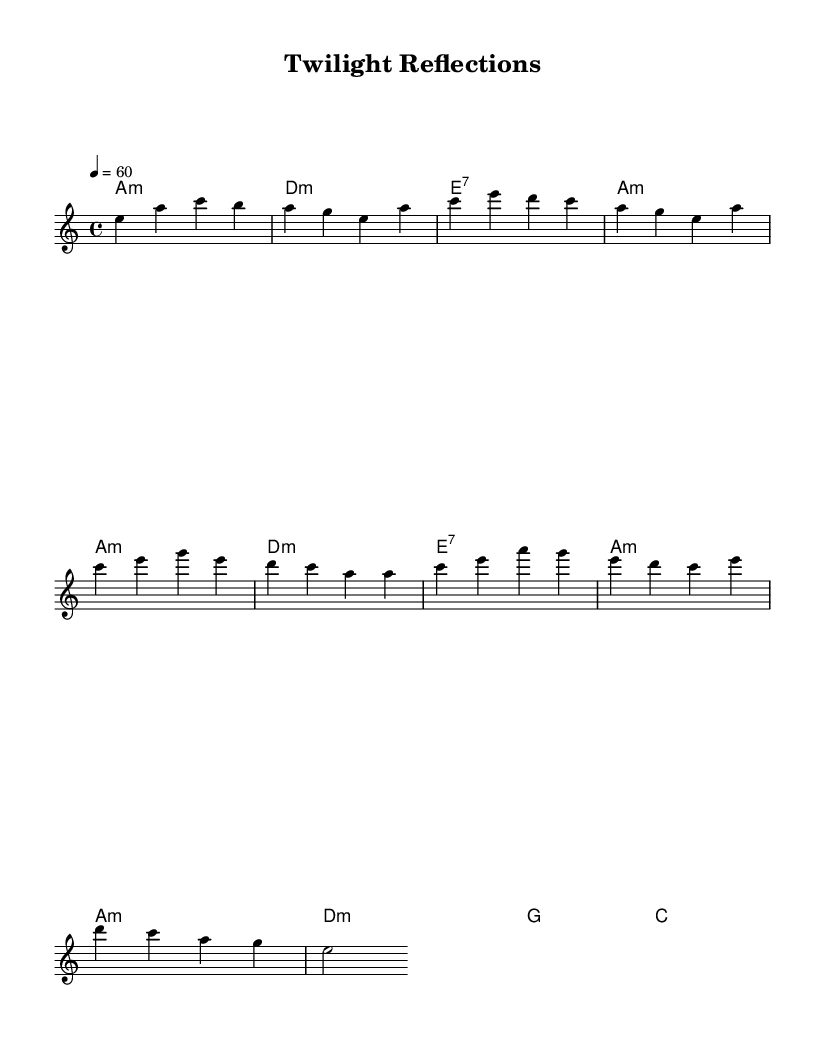What is the key signature of this music? The key signature is A minor, which has no sharps or flats indicated in the music sheet.
Answer: A minor What is the time signature? The time signature is indicated at the beginning of the music as 4/4, meaning there are four beats in each measure.
Answer: 4/4 What is the tempo marking for this piece? The tempo marking indicates a speed of 60 beats per minute, as noted at the beginning of the score.
Answer: 60 How many measures are in the intro? The intro consists of four measures, as outlined before the first verse begins.
Answer: 4 What is the primary chord used in the chorus? The primary chord used at the beginning of the chorus is A minor, which is indicated after the melody notes are presented.
Answer: A minor How would you describe the overall style of this music? The overall style can be described as a slow, soulful blues ballad, characterized by its emotive melody and reflective lyrics.
Answer: Slow, soulful blues ballad What is the structural feature of blues in this score? The structural feature is the use of a repetitive chord progression, which is characteristic of blues music, providing a strong foundation for improvisation.
Answer: Repetitive chord progression 